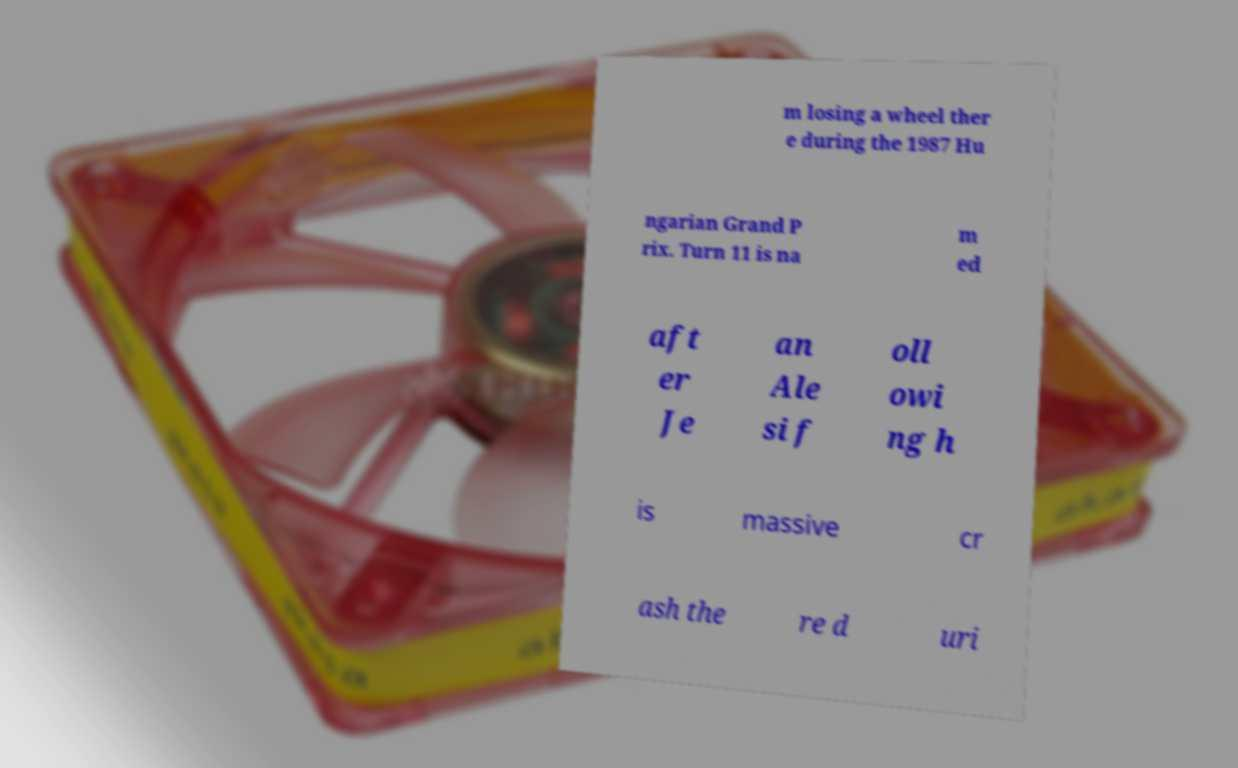There's text embedded in this image that I need extracted. Can you transcribe it verbatim? m losing a wheel ther e during the 1987 Hu ngarian Grand P rix. Turn 11 is na m ed aft er Je an Ale si f oll owi ng h is massive cr ash the re d uri 